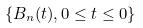Convert formula to latex. <formula><loc_0><loc_0><loc_500><loc_500>\{ B _ { n } ( t ) , 0 \leq t \leq 0 \}</formula> 